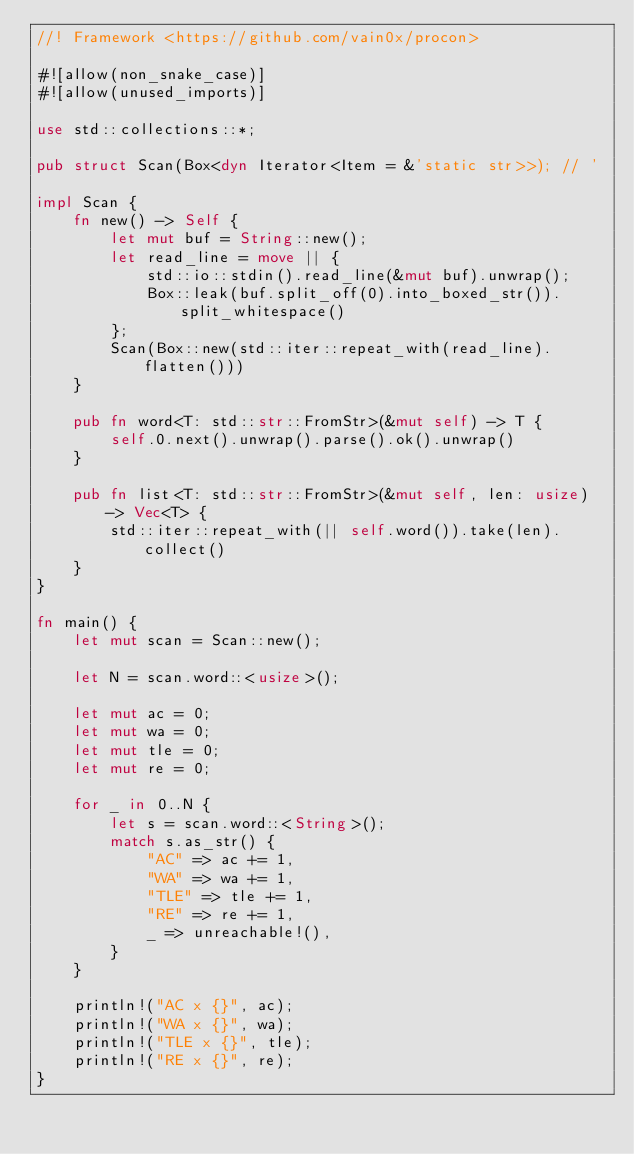<code> <loc_0><loc_0><loc_500><loc_500><_Rust_>//! Framework <https://github.com/vain0x/procon>

#![allow(non_snake_case)]
#![allow(unused_imports)]

use std::collections::*;

pub struct Scan(Box<dyn Iterator<Item = &'static str>>); // '

impl Scan {
    fn new() -> Self {
        let mut buf = String::new();
        let read_line = move || {
            std::io::stdin().read_line(&mut buf).unwrap();
            Box::leak(buf.split_off(0).into_boxed_str()).split_whitespace()
        };
        Scan(Box::new(std::iter::repeat_with(read_line).flatten()))
    }

    pub fn word<T: std::str::FromStr>(&mut self) -> T {
        self.0.next().unwrap().parse().ok().unwrap()
    }

    pub fn list<T: std::str::FromStr>(&mut self, len: usize) -> Vec<T> {
        std::iter::repeat_with(|| self.word()).take(len).collect()
    }
}

fn main() {
    let mut scan = Scan::new();

    let N = scan.word::<usize>();

    let mut ac = 0;
    let mut wa = 0;
    let mut tle = 0;
    let mut re = 0;

    for _ in 0..N {
        let s = scan.word::<String>();
        match s.as_str() {
            "AC" => ac += 1,
            "WA" => wa += 1,
            "TLE" => tle += 1,
            "RE" => re += 1,
            _ => unreachable!(),
        }
    }

    println!("AC x {}", ac);
    println!("WA x {}", wa);
    println!("TLE x {}", tle);
    println!("RE x {}", re);
}
</code> 